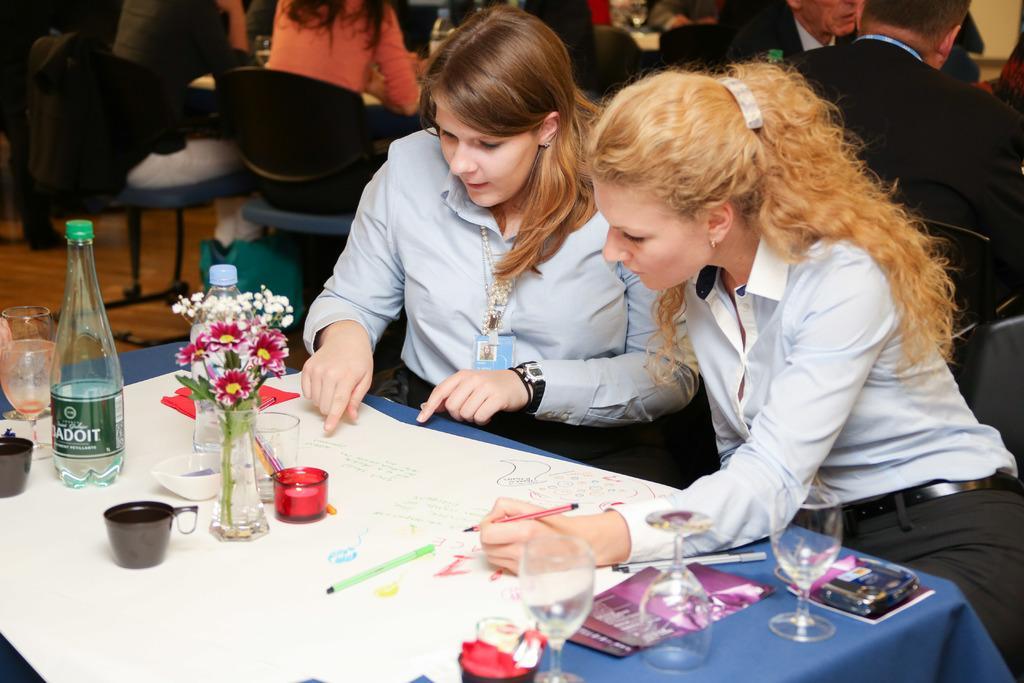Could you give a brief overview of what you see in this image? In this image we can see two persons are sitting on the chair, and holding the pen in the hand, and here is the table and glass and bottle and some objects on it, and at back here are the group of persons are sitting. 